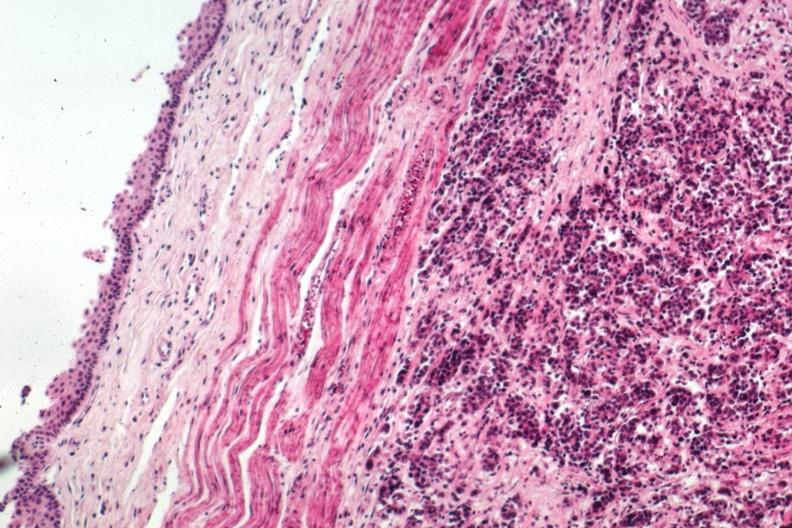what is present?
Answer the question using a single word or phrase. Metastatic carcinoma breast 